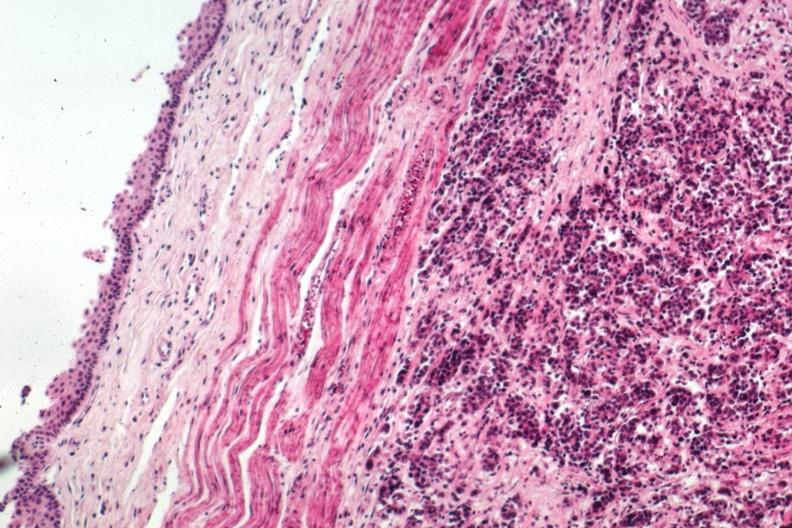what is present?
Answer the question using a single word or phrase. Metastatic carcinoma breast 